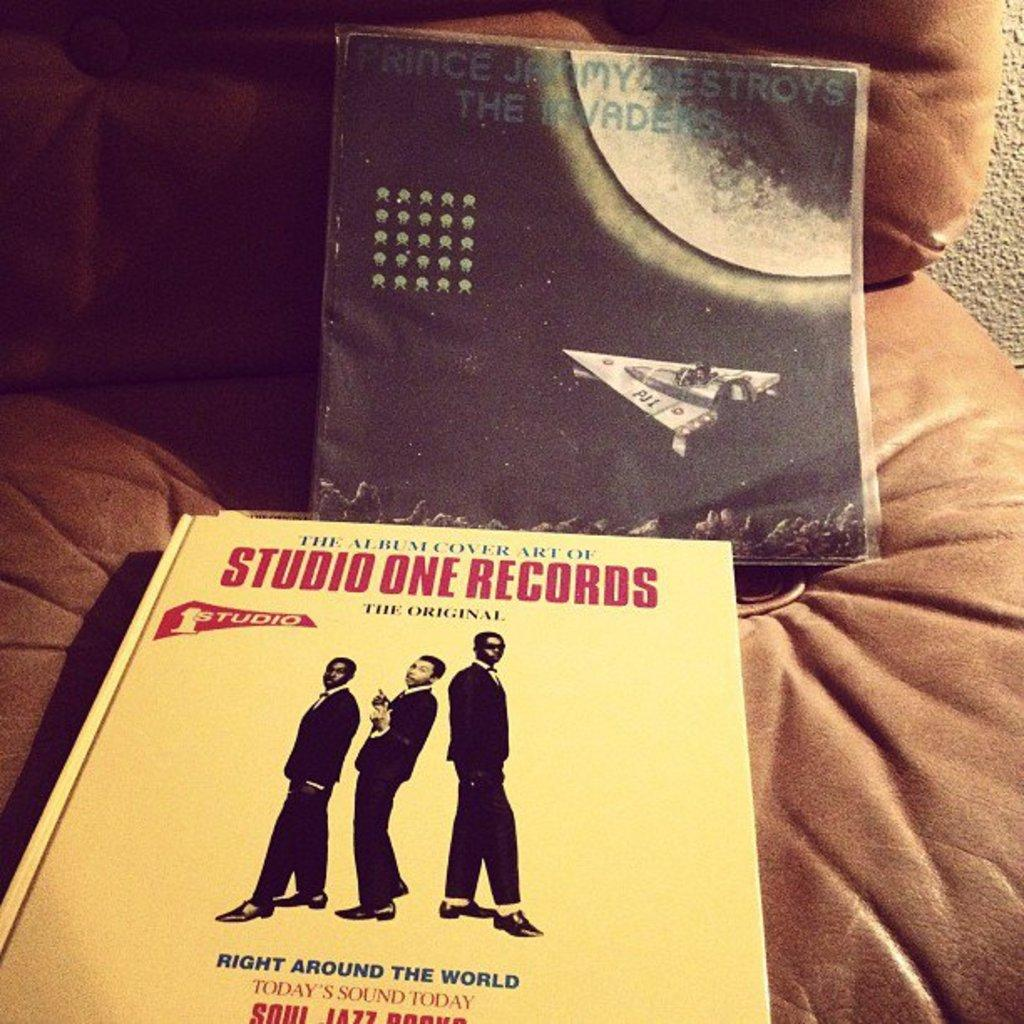<image>
Relay a brief, clear account of the picture shown. A book from Studio One Records sits on a brown leather sofa 